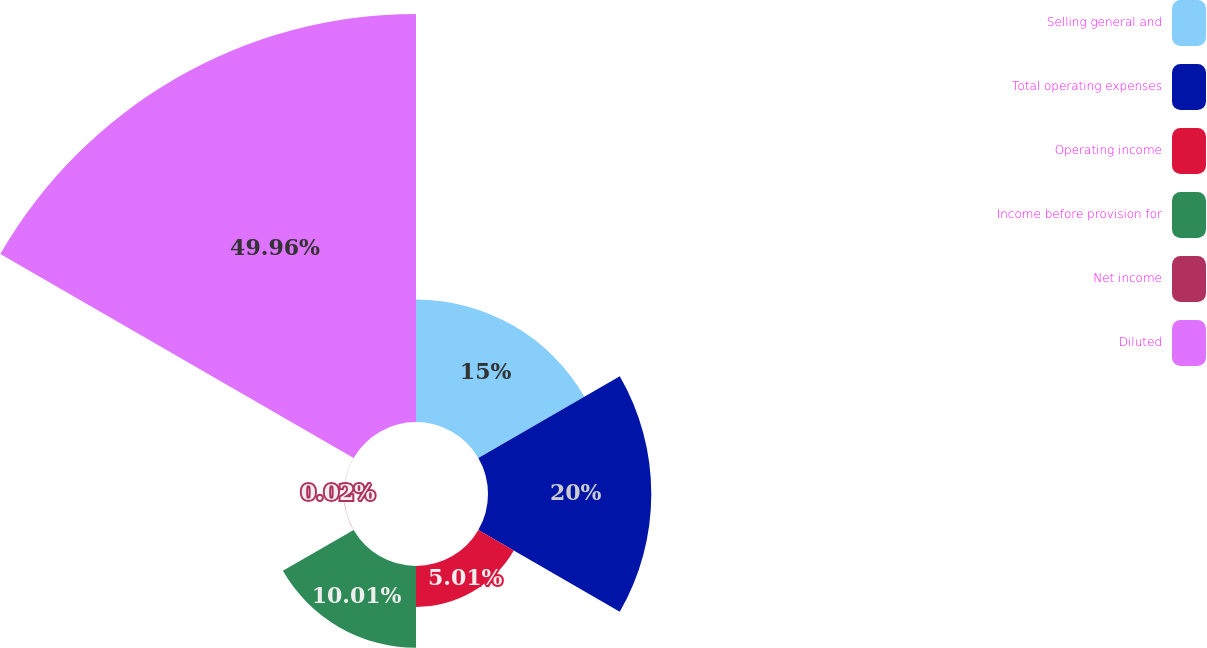Convert chart to OTSL. <chart><loc_0><loc_0><loc_500><loc_500><pie_chart><fcel>Selling general and<fcel>Total operating expenses<fcel>Operating income<fcel>Income before provision for<fcel>Net income<fcel>Diluted<nl><fcel>15.0%<fcel>20.0%<fcel>5.01%<fcel>10.01%<fcel>0.02%<fcel>49.97%<nl></chart> 